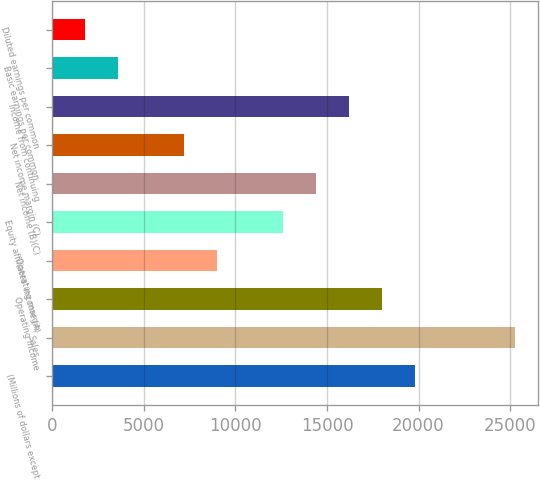Convert chart to OTSL. <chart><loc_0><loc_0><loc_500><loc_500><bar_chart><fcel>(Millions of dollars except<fcel>Sales<fcel>Operating income<fcel>Operating margin<fcel>Equity affiliates' income (A)<fcel>Net income (B)(C)<fcel>Net income margin (C)<fcel>Income from continuing<fcel>Basic earnings per common<fcel>Diluted earnings per common<nl><fcel>19831.5<fcel>25239.2<fcel>18029<fcel>9016.19<fcel>12621.3<fcel>14423.9<fcel>7213.63<fcel>16226.4<fcel>3608.51<fcel>1805.95<nl></chart> 